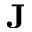<formula> <loc_0><loc_0><loc_500><loc_500>J</formula> 